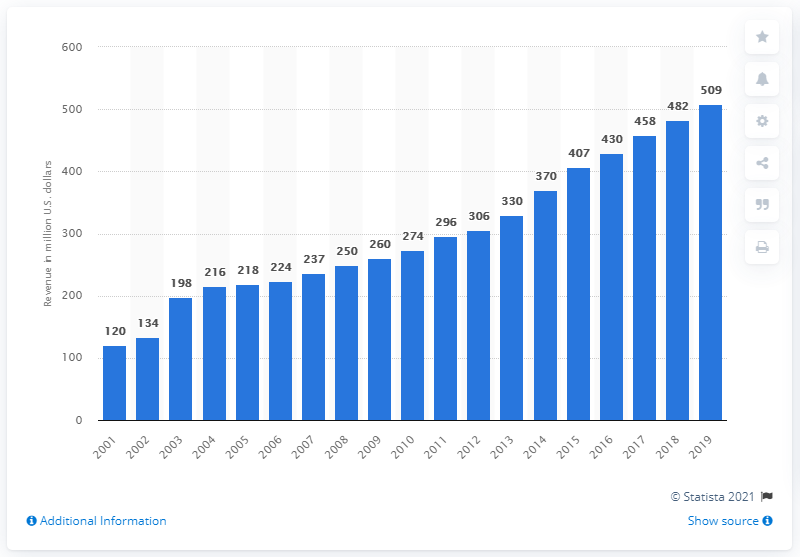Indicate a few pertinent items in this graphic. The revenue of the Philadelphia Eagles in 2019 was $509 million. 